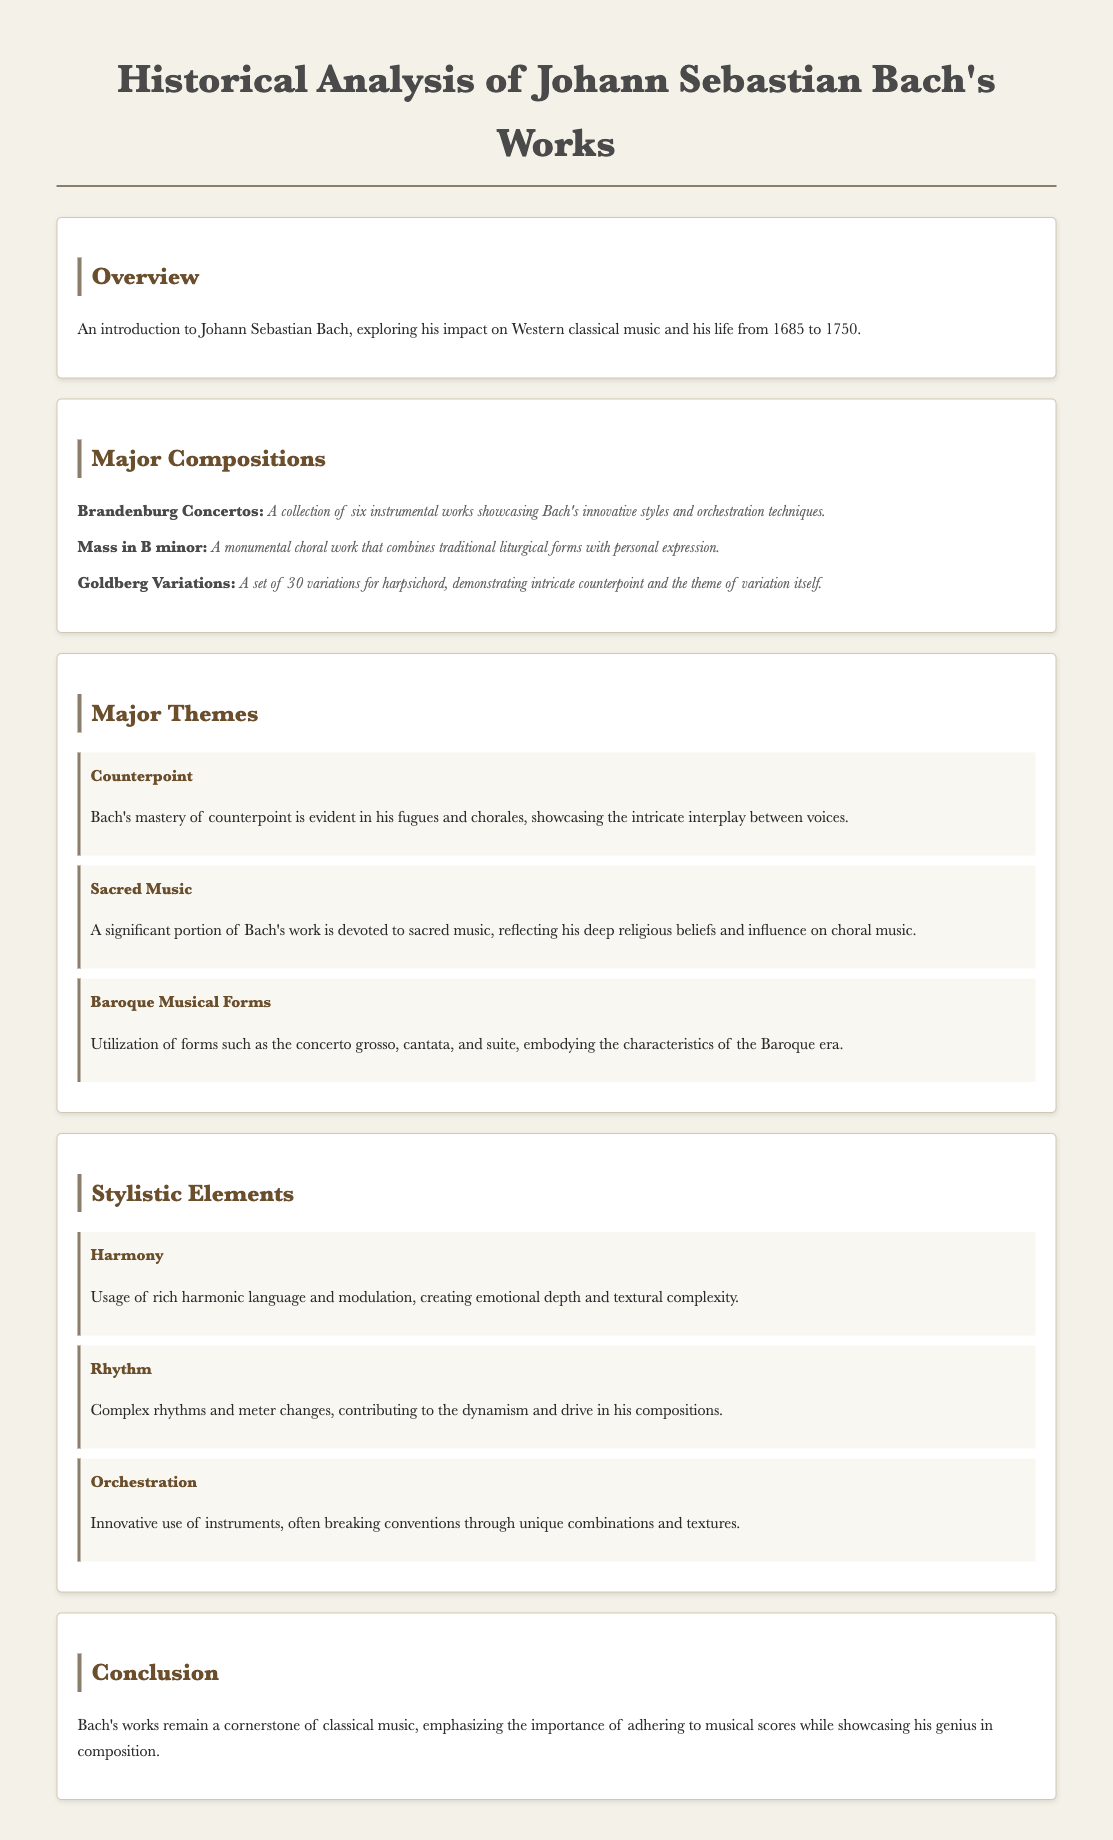What are the dates of Johann Sebastian Bach's life? The document states that Bach lived from 1685 to 1750.
Answer: 1685 to 1750 What is the title of Bach's monumental choral work? The document mentions "Mass in B minor" as a monumental choral work.
Answer: Mass in B minor How many Brandenburg Concertos did Bach compose? The document lists six instrumental works as the Brandenburg Concertos.
Answer: Six What major theme reflects Bach's religious beliefs? The document highlights "Sacred Music" as a theme reflecting his beliefs.
Answer: Sacred Music Which stylistic element describes Bach's use of instruments? The document mentions "Orchestration" as a stylistic element of Bach's work.
Answer: Orchestration What musical form is mentioned as being utilized by Bach? The document includes "concerto grosso" as a form used in his work.
Answer: Concerto grosso What type of music comprises a significant portion of Bach's work? The document indicates that "sacred music" is significant in his oeuvre.
Answer: Sacred music In what year was Bach born? According to the document, Bach was born in 1685.
Answer: 1685 